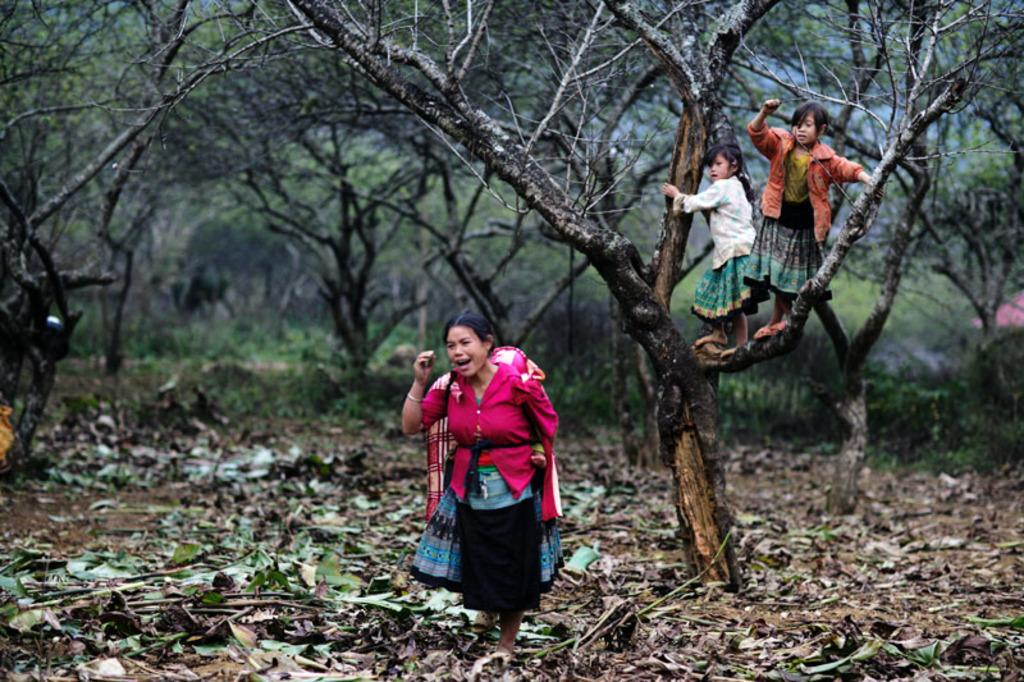How many people are in the image? There are a few people in the image. What type of vegetation can be seen in the image? There are plants and trees in the image. What is visible beneath the people and vegetation in the image? The ground is visible in the image. What can be found on the ground in the image? There are objects like dried leaves on the ground. Where is the object located in the image? There is an object on the right side of the image. How does the bridge act as a support in the image? There is no bridge present in the image, so it cannot act as a support. 